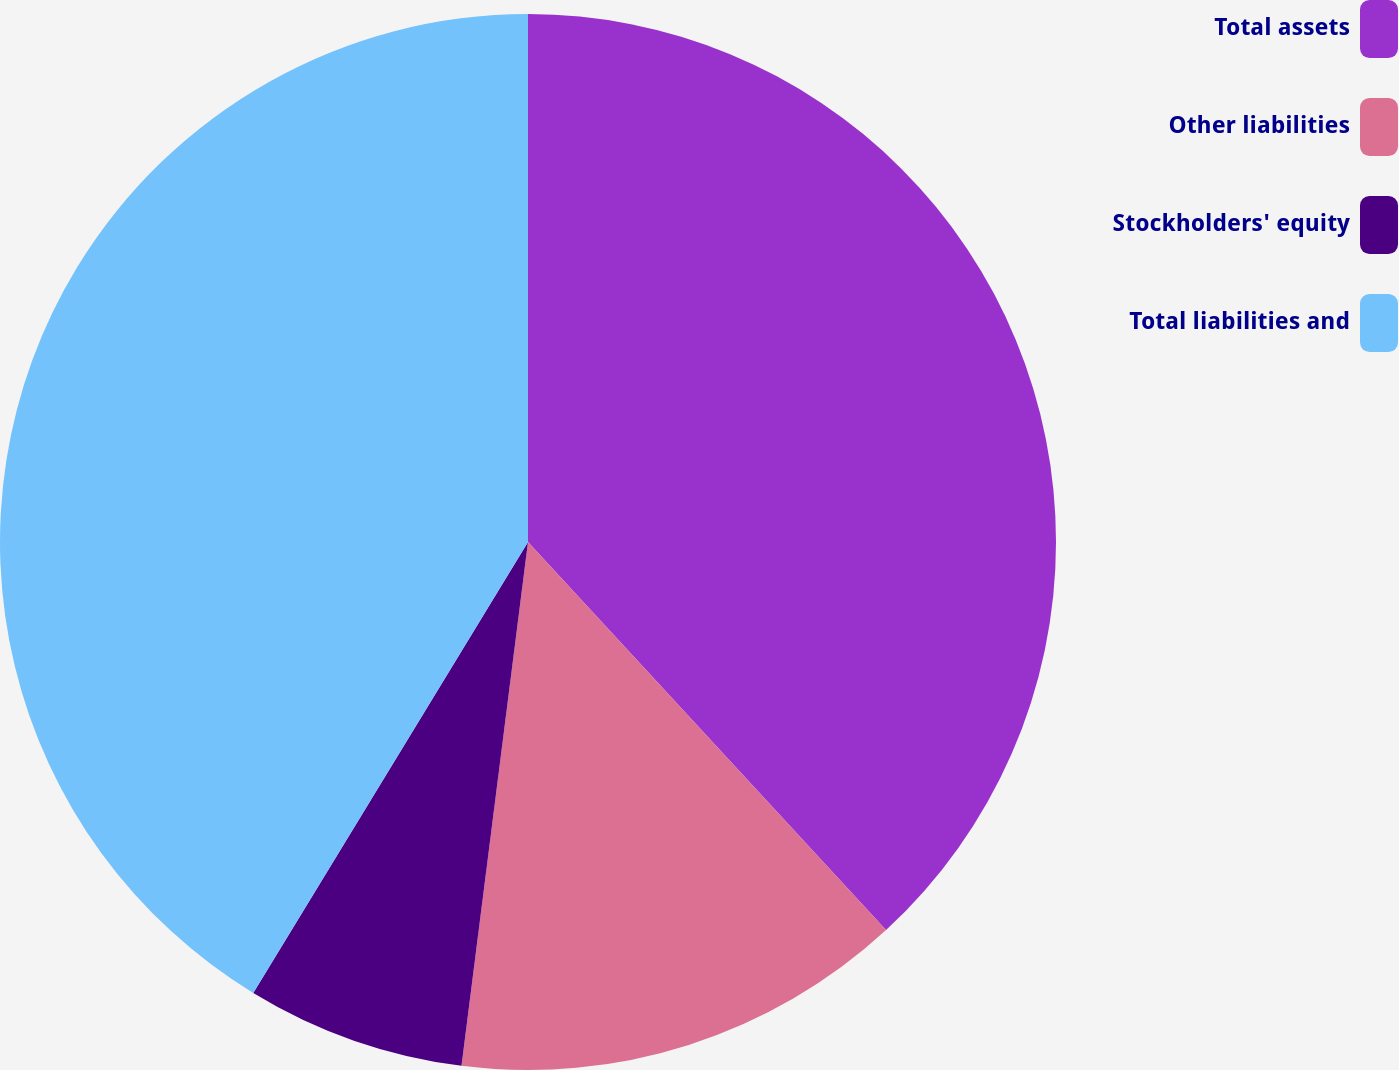<chart> <loc_0><loc_0><loc_500><loc_500><pie_chart><fcel>Total assets<fcel>Other liabilities<fcel>Stockholders' equity<fcel>Total liabilities and<nl><fcel>38.14%<fcel>13.87%<fcel>6.7%<fcel>41.29%<nl></chart> 